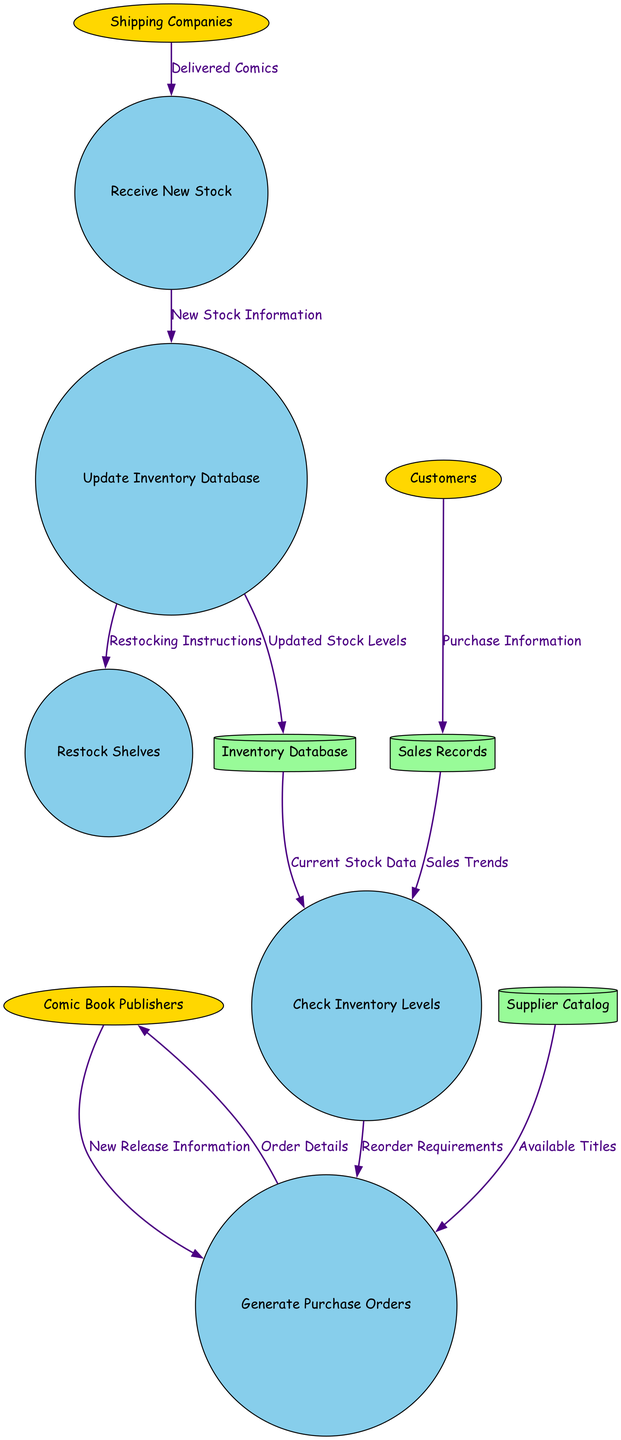What are the external entities in the diagram? The external entities listed in the diagram are Comic Book Publishers, Customers, and Shipping Companies. These entities interact with the processes of the comic book store's inventory management.
Answer: Comic Book Publishers, Customers, Shipping Companies How many processes are shown in the diagram? The diagram includes five distinct processes: Check Inventory Levels, Generate Purchase Orders, Receive New Stock, Update Inventory Database, and Restock Shelves.
Answer: Five What data flows from Shipping Companies to the inventory process? The data that flows from Shipping Companies to the process is labeled as Delivered Comics. This data is crucial for updating the inventory after new stock is received.
Answer: Delivered Comics Which process updates the inventory database? The process that updates the inventory database is called Update Inventory Database. This process incorporates new stock information into the system for accurate inventory management.
Answer: Update Inventory Database What flows from the Inventory Database to the Check Inventory Levels process? The flow from the Inventory Database to the Check Inventory Levels process is labeled Current Stock Data. This data is vital for assessing available inventory before generating new orders.
Answer: Current Stock Data How does the process Generate Purchase Orders determine when to reorder stock? The Generate Purchase Orders process receives Reorder Requirements from both Check Inventory Levels and Sales Trends, which cumulatively indicate the need to reorder stock based on current data and sales history.
Answer: Reorder Requirements What is the final action taken in the comic book store's inventory process? The final action outlined in the diagram is Restock Shelves. This step ensures that the comic books are placed back on display for customers after the inventory has been updated with new stock.
Answer: Restock Shelves Which data store receives Purchase Information from Customers? The data store that receives Purchase Information from Customers is called Sales Records. This store keeps track of transactions made by customers.
Answer: Sales Records What instruction is sent to the Restock Shelves process? The instruction sent to the Restock Shelves process is labeled Restocking Instructions. This data determines how the new stock should be organized on the shelves.
Answer: Restocking Instructions 